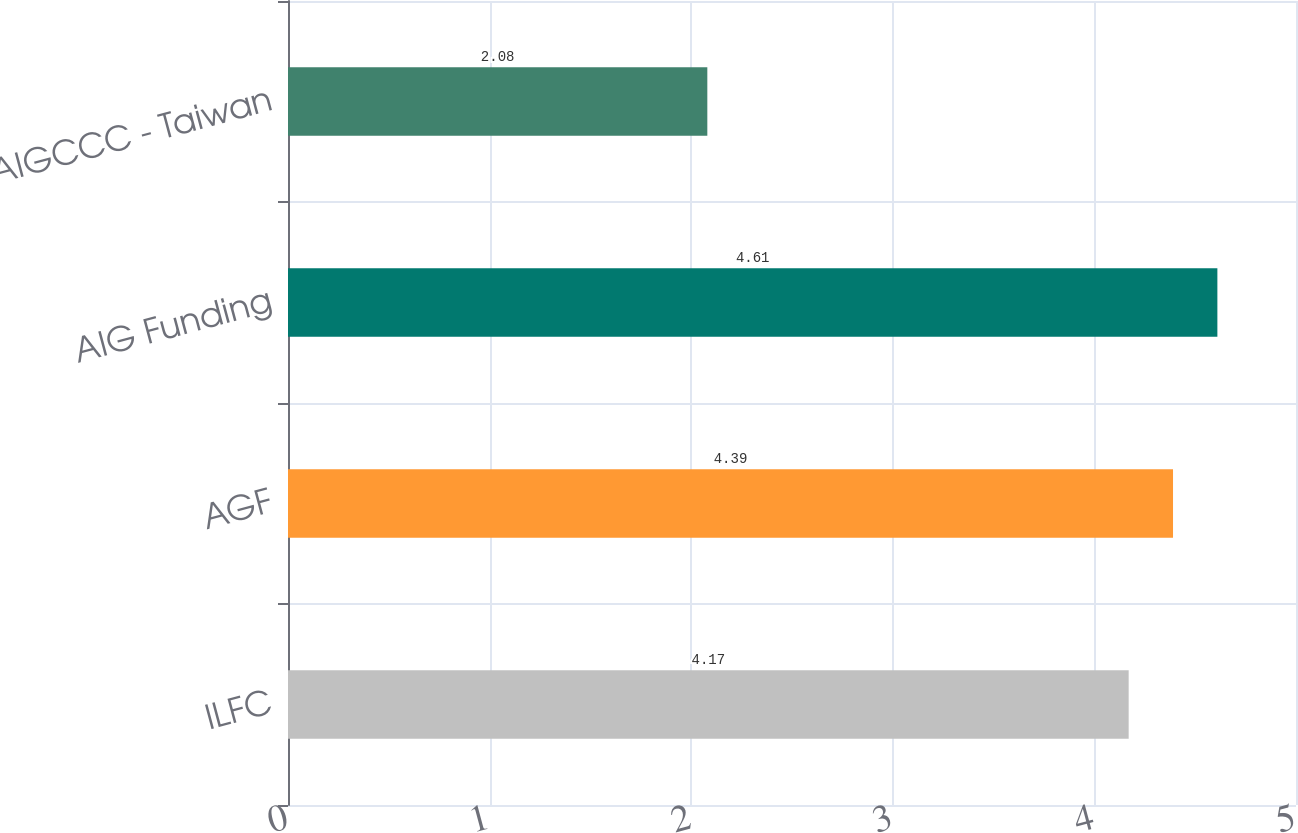Convert chart to OTSL. <chart><loc_0><loc_0><loc_500><loc_500><bar_chart><fcel>ILFC<fcel>AGF<fcel>AIG Funding<fcel>AIGCCC - Taiwan<nl><fcel>4.17<fcel>4.39<fcel>4.61<fcel>2.08<nl></chart> 